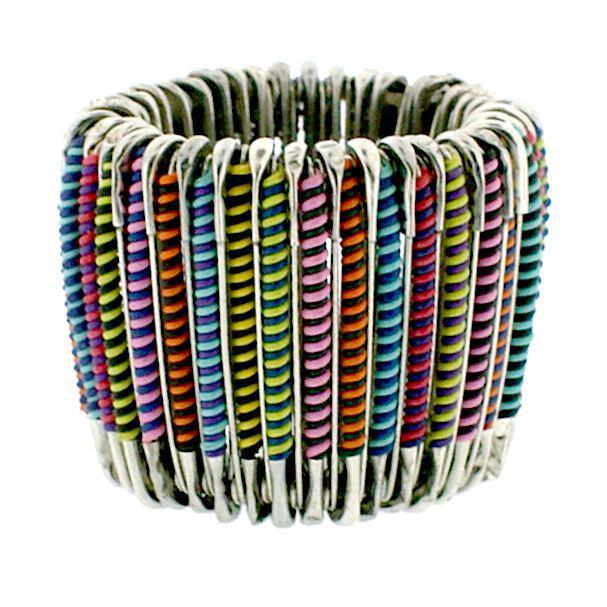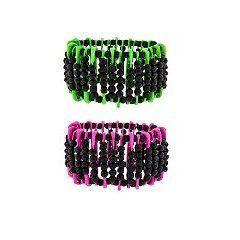The first image is the image on the left, the second image is the image on the right. For the images displayed, is the sentence "An image features a beaded bracelet displayed by a black item." factually correct? Answer yes or no. No. The first image is the image on the left, the second image is the image on the right. Analyze the images presented: Is the assertion "There are two unworn bracelets" valid? Answer yes or no. No. 